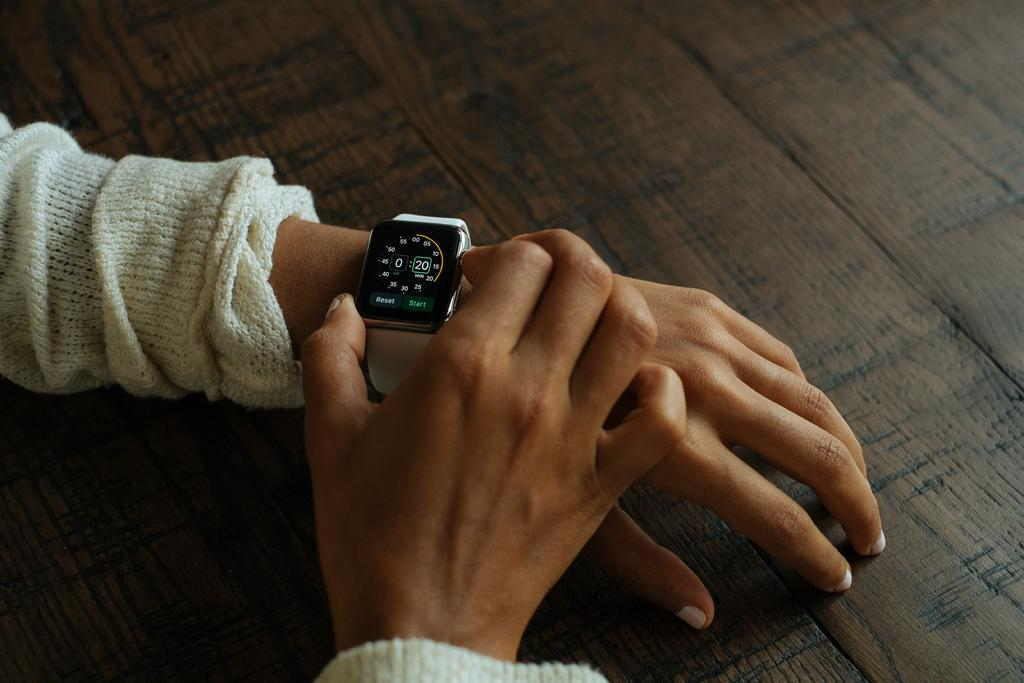Provide a one-sentence caption for the provided image. A person in a white shirt is setting their smart watch for a 20 minute timer. 